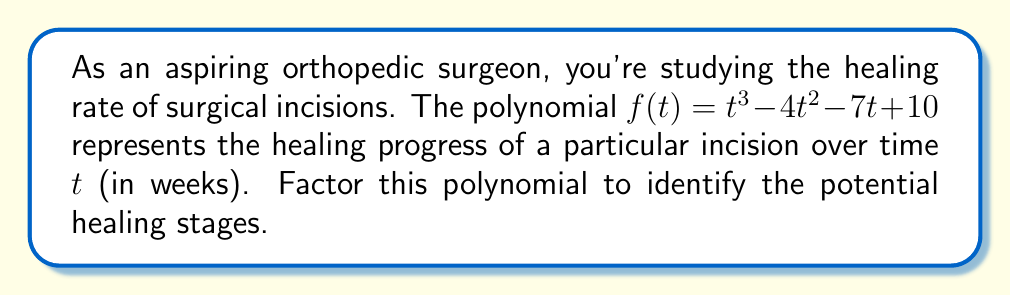Could you help me with this problem? Let's approach this step-by-step:

1) First, we'll check if there are any rational roots using the rational root theorem. The possible rational roots are the factors of the constant term: ±1, ±2, ±5, ±10.

2) Testing these values, we find that f(1) = 0. So (t - 1) is a factor.

3) We can use polynomial long division to divide f(t) by (t - 1):

   $$t^3 - 4t^2 - 7t + 10 = (t - 1)(t^2 - 3t - 10)$$

4) Now we need to factor the quadratic term $t^2 - 3t - 10$:

   a) The product of the roots is -10
   b) The sum of the roots is 3

5) The factors that satisfy these conditions are 5 and -2.

6) Therefore, $t^2 - 3t - 10 = (t - 5)(t + 2)$

7) Combining all factors:

   $$f(t) = (t - 1)(t - 5)(t + 2)$$

This factorization reveals three potential stages in the healing process, occurring at 1 week, 5 weeks, and -2 weeks (which isn't meaningful in this context, but mathematically completes the factorization).
Answer: $(t - 1)(t - 5)(t + 2)$ 